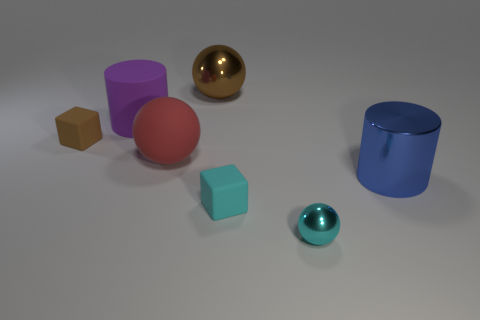What number of purple objects are either matte cylinders or large rubber spheres?
Keep it short and to the point. 1. What number of other things are there of the same shape as the tiny brown object?
Provide a succinct answer. 1. Is the material of the blue cylinder the same as the small brown thing?
Ensure brevity in your answer.  No. There is a large object that is both on the left side of the tiny sphere and in front of the brown matte object; what material is it?
Provide a short and direct response. Rubber. There is a metal sphere in front of the cyan matte thing; what is its color?
Your answer should be very brief. Cyan. Is the number of large red spheres that are in front of the small cyan sphere greater than the number of small things?
Your response must be concise. No. How many other things are the same size as the cyan matte block?
Your answer should be very brief. 2. There is a big purple rubber thing; how many red rubber objects are on the right side of it?
Offer a terse response. 1. Is the number of big blue metallic cylinders behind the large rubber ball the same as the number of blocks that are behind the big metallic ball?
Your response must be concise. Yes. What size is the rubber thing that is the same shape as the large brown metallic thing?
Keep it short and to the point. Large. 